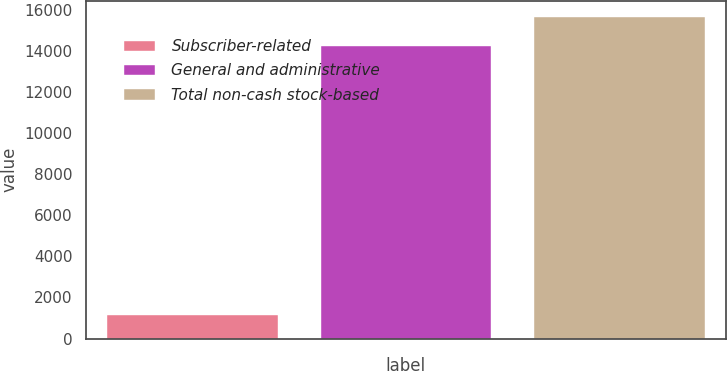Convert chart. <chart><loc_0><loc_0><loc_500><loc_500><bar_chart><fcel>Subscriber-related<fcel>General and administrative<fcel>Total non-cash stock-based<nl><fcel>1160<fcel>14227<fcel>15649.7<nl></chart> 